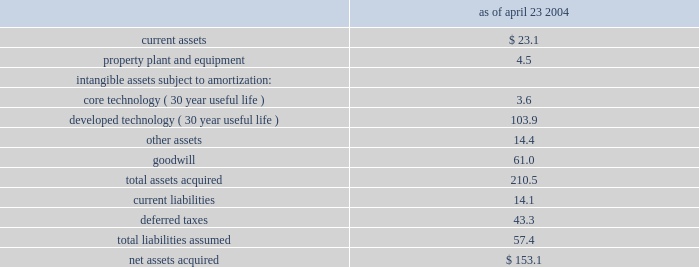Z i m m e r h o l d i n g s , i n c .
A n d s u b s i d i a r i e s 2 0 0 4 f o r m 1 0 - k notes to consolidated financial statements ( continued ) the company and implex had been operating since 2000 , the table summarizes the estimated fair values relating to the development and distribution of reconstructive of the assets acquired and liabilities assumed at the date of implant and trauma products incorporating trabecular metal the implex acquisition : ( in millions ) technology .
As ofthe merger agreement contains provisions for additional april 23 , 2004annual cash earn-out payments that are based on year-over- current assets $ 23.1year sales growth through 2006 of certain products that .
Estimates total earn-out payments , including payments core technology ( 30 year useful life ) 3.6 already made , to be in a range from $ 120 to $ 160 million .
Developed technology ( 30 year useful life ) 103.9 other assets 14.4these earn-out payments represent contingent consideration goodwill 61.0and , in accordance with sfas no .
141 and eitf 95-8 2018 2018accounting for contingent consideration paid to the total assets acquired 210.5 shareholders of an acquired enterprise in a purchase current liabilities 14.1 deferred taxes 43.3business combination 2019 2019 , are recorded as an additional cost of the transaction upon resolution of the contingency and total liabilities assumed 57.4 therefore increase goodwill .
Net assets acquired $ 153.1the implex acquisition was accounted for under the purchase method of accounting pursuant to sfas no .
141 .
Change in accounting principle accordingly , implex results of operations have been included in the company 2019s consolidated results of operations instruments are hand held devices used by orthopaedic subsequent to april 23 , 2004 , and its respective assets and surgeons during total joint replacement and other surgical liabilities have been recorded at their estimated fair values in procedures .
Effective january 1 , 2003 , instruments are the company 2019s consolidated statement of financial position as recognized as long-lived assets and are included in property , of april 23 , 2004 , with the excess purchase price being plant and equipment .
Undeployed instruments are carried at allocated to goodwill .
Pro forma financial information has not cost , net of allowances for obsolescence .
Instruments in the been included as the acquisition did not have a material field are carried at cost less accumulated depreciation .
Impact upon the company 2019s financial position , results of depreciation is computed using the straight-line method operations or cash flows .
Based on average estimated useful lives , determined the company completed the preliminary purchase price principally in reference to associated product life cycles , allocation in accordance with u.s .
Generally accepted primarily five years .
In accordance with sfas no .
144 , the accounting principles .
The process included interviews with company reviews instruments for impairment whenever management , review of the economic and competitive events or changes in circumstances indicate that the carrying environment and examination of assets including historical value of an asset may not be recoverable .
An impairment loss performance and future prospects .
The preliminary purchase would be recognized when estimated future cash flows price allocation was based on information currently available relating to the asset are less than its carrying amount .
To the company , and expectations and assumptions deemed depreciation of instruments is recognized as selling , general reasonable by the company 2019s management .
No assurance can and administrative expense , consistent with the classification be given , however , that the underlying assumptions used to of instrument cost in periods prior to january 1 , 2003 .
Estimate expected technology based product revenues , prior to january 1 , 2003 , undeployed instruments were development costs or profitability , or the events associated carried as a prepaid expense at cost , net of allowances for with such technology , will occur as projected .
The final obsolescence ( $ 54.8 million , net , at december 31 , 2002 ) , and purchase price allocation may vary from the preliminary recognized in selling , general and administrative expense in purchase price allocation .
The final valuation and associated the year in which the instruments were placed into service .
Purchase price allocation is expected to be completed as the new method of accounting for instruments was adopted soon as possible , but no later than one year from the date of to recognize the cost of these important assets of the acquisition .
To the extent that the estimates need to be company 2019s business within the consolidated balance sheet adjusted , the company will do so .
And meaningfully allocate the cost of these assets over the periods benefited , typically five years .
The effect of the change during the year ended december 31 , 2003 was to increase earnings before cumulative effect of change in accounting principle by $ 26.8 million ( $ 17.8 million net of tax ) , or $ 0.08 per diluted share .
The cumulative effect adjustment of $ 55.1 million ( net of income taxes of $ 34.0 million ) to retroactively apply the .
What is goodwill as a percentage of net assets acquired? 
Computations: (61.0 / 153.1)
Answer: 0.39843. 